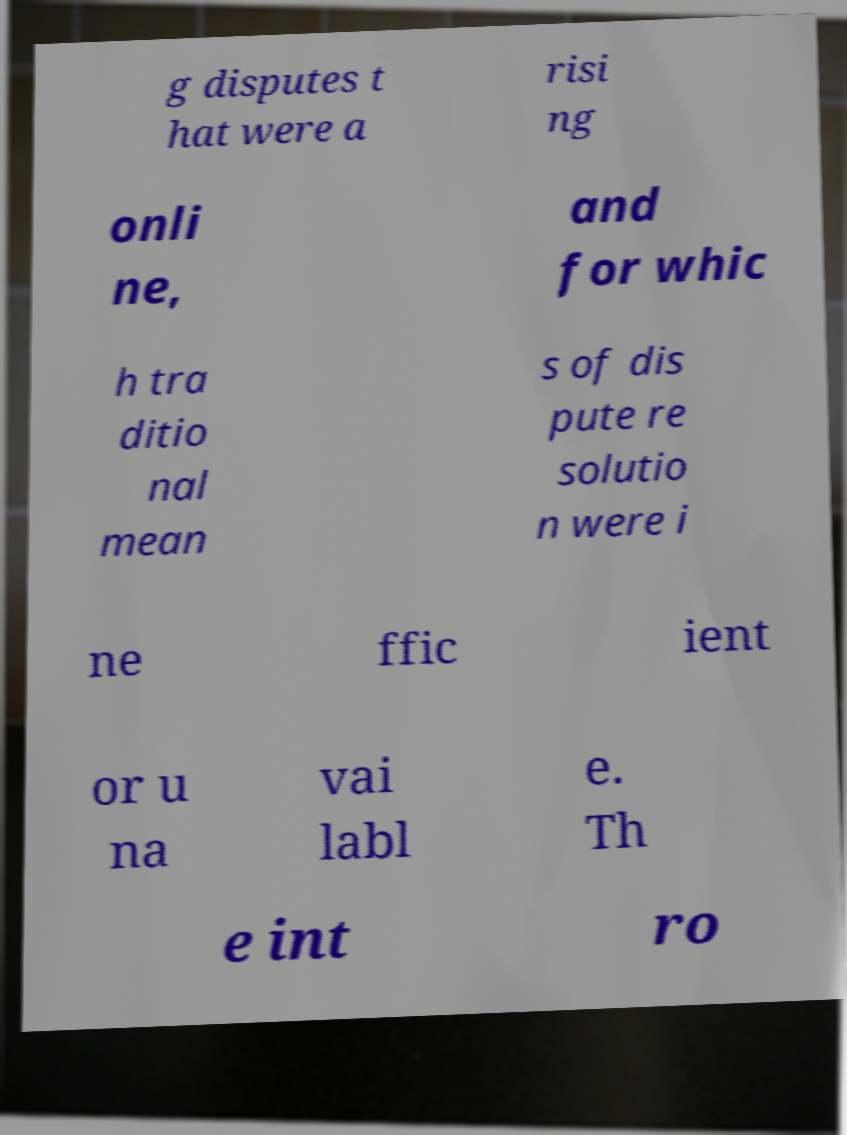Could you extract and type out the text from this image? g disputes t hat were a risi ng onli ne, and for whic h tra ditio nal mean s of dis pute re solutio n were i ne ffic ient or u na vai labl e. Th e int ro 